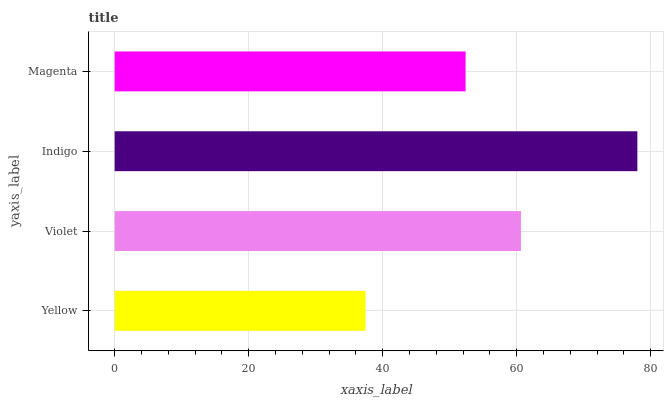Is Yellow the minimum?
Answer yes or no. Yes. Is Indigo the maximum?
Answer yes or no. Yes. Is Violet the minimum?
Answer yes or no. No. Is Violet the maximum?
Answer yes or no. No. Is Violet greater than Yellow?
Answer yes or no. Yes. Is Yellow less than Violet?
Answer yes or no. Yes. Is Yellow greater than Violet?
Answer yes or no. No. Is Violet less than Yellow?
Answer yes or no. No. Is Violet the high median?
Answer yes or no. Yes. Is Magenta the low median?
Answer yes or no. Yes. Is Magenta the high median?
Answer yes or no. No. Is Indigo the low median?
Answer yes or no. No. 